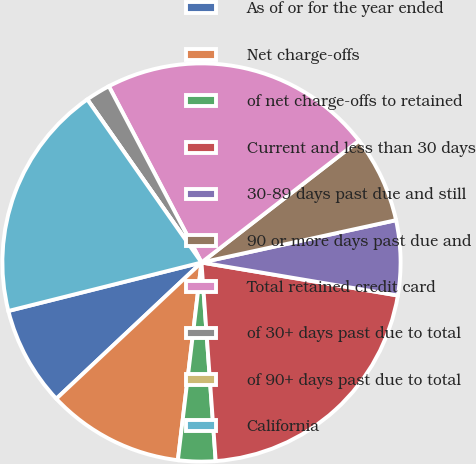<chart> <loc_0><loc_0><loc_500><loc_500><pie_chart><fcel>As of or for the year ended<fcel>Net charge-offs<fcel>of net charge-offs to retained<fcel>Current and less than 30 days<fcel>30-89 days past due and still<fcel>90 or more days past due and<fcel>Total retained credit card<fcel>of 30+ days past due to total<fcel>of 90+ days past due to total<fcel>California<nl><fcel>8.08%<fcel>11.11%<fcel>3.03%<fcel>21.21%<fcel>6.06%<fcel>7.07%<fcel>22.22%<fcel>2.02%<fcel>0.0%<fcel>19.19%<nl></chart> 